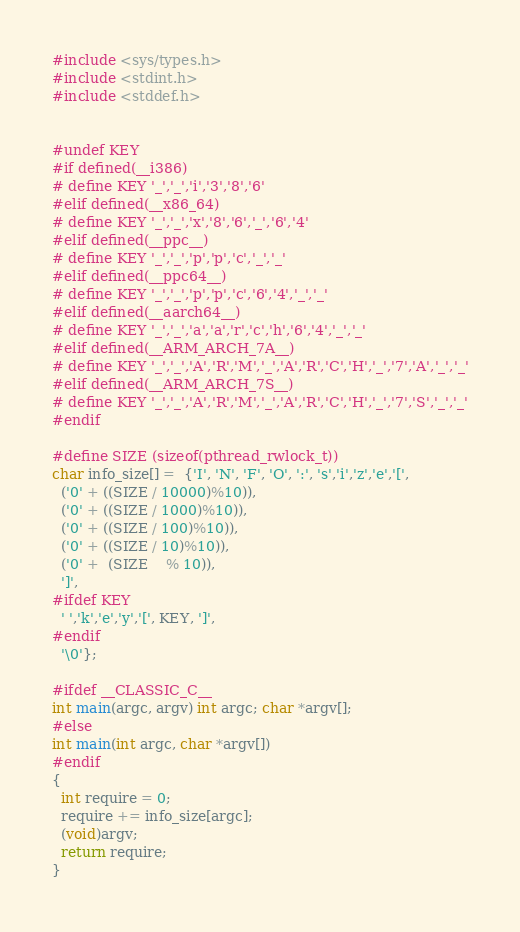Convert code to text. <code><loc_0><loc_0><loc_500><loc_500><_C++_>#include <sys/types.h>
#include <stdint.h>
#include <stddef.h>


#undef KEY
#if defined(__i386)
# define KEY '_','_','i','3','8','6'
#elif defined(__x86_64)
# define KEY '_','_','x','8','6','_','6','4'
#elif defined(__ppc__)
# define KEY '_','_','p','p','c','_','_'
#elif defined(__ppc64__)
# define KEY '_','_','p','p','c','6','4','_','_'
#elif defined(__aarch64__)
# define KEY '_','_','a','a','r','c','h','6','4','_','_'
#elif defined(__ARM_ARCH_7A__)
# define KEY '_','_','A','R','M','_','A','R','C','H','_','7','A','_','_'
#elif defined(__ARM_ARCH_7S__)
# define KEY '_','_','A','R','M','_','A','R','C','H','_','7','S','_','_'
#endif

#define SIZE (sizeof(pthread_rwlock_t))
char info_size[] =  {'I', 'N', 'F', 'O', ':', 's','i','z','e','[',
  ('0' + ((SIZE / 10000)%10)),
  ('0' + ((SIZE / 1000)%10)),
  ('0' + ((SIZE / 100)%10)),
  ('0' + ((SIZE / 10)%10)),
  ('0' +  (SIZE    % 10)),
  ']',
#ifdef KEY
  ' ','k','e','y','[', KEY, ']',
#endif
  '\0'};

#ifdef __CLASSIC_C__
int main(argc, argv) int argc; char *argv[];
#else
int main(int argc, char *argv[])
#endif
{
  int require = 0;
  require += info_size[argc];
  (void)argv;
  return require;
}
</code> 